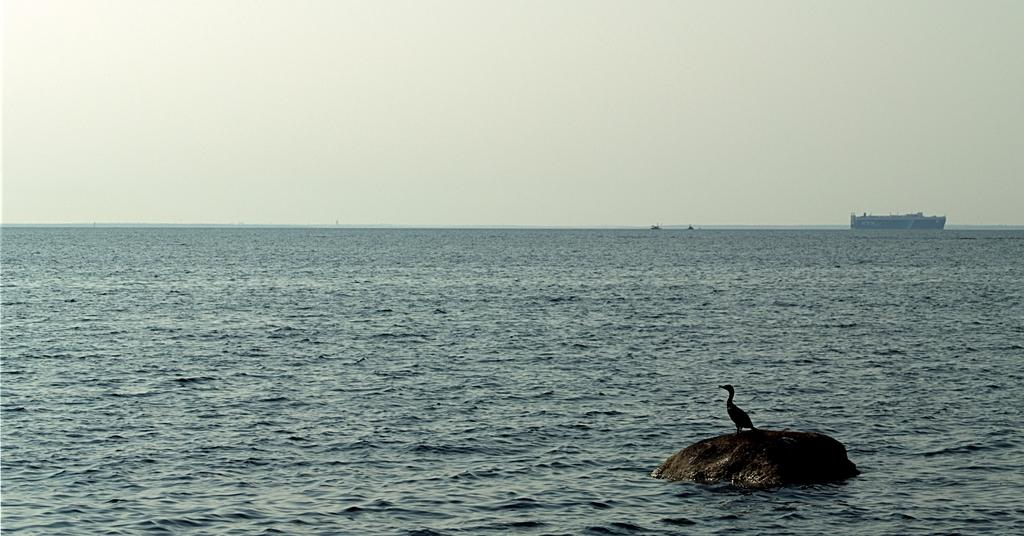What is the main setting of the image? The main setting of the image is the sea. What is present on the sea in the image? There is a boat on the sea in the image. What other living creature can be seen in the image? A bird is visible on a stone in the image. What is visible at the top of the image? The sky is visible at the top of the image. Where is the cat sitting in the image? There is no cat present in the image. What type of lake can be seen in the image? The image does not depict a lake; it features the sea. 